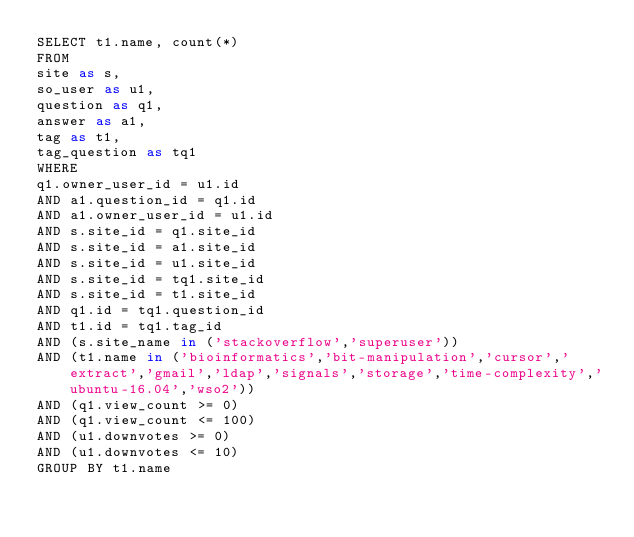<code> <loc_0><loc_0><loc_500><loc_500><_SQL_>SELECT t1.name, count(*)
FROM
site as s,
so_user as u1,
question as q1,
answer as a1,
tag as t1,
tag_question as tq1
WHERE
q1.owner_user_id = u1.id
AND a1.question_id = q1.id
AND a1.owner_user_id = u1.id
AND s.site_id = q1.site_id
AND s.site_id = a1.site_id
AND s.site_id = u1.site_id
AND s.site_id = tq1.site_id
AND s.site_id = t1.site_id
AND q1.id = tq1.question_id
AND t1.id = tq1.tag_id
AND (s.site_name in ('stackoverflow','superuser'))
AND (t1.name in ('bioinformatics','bit-manipulation','cursor','extract','gmail','ldap','signals','storage','time-complexity','ubuntu-16.04','wso2'))
AND (q1.view_count >= 0)
AND (q1.view_count <= 100)
AND (u1.downvotes >= 0)
AND (u1.downvotes <= 10)
GROUP BY t1.name</code> 